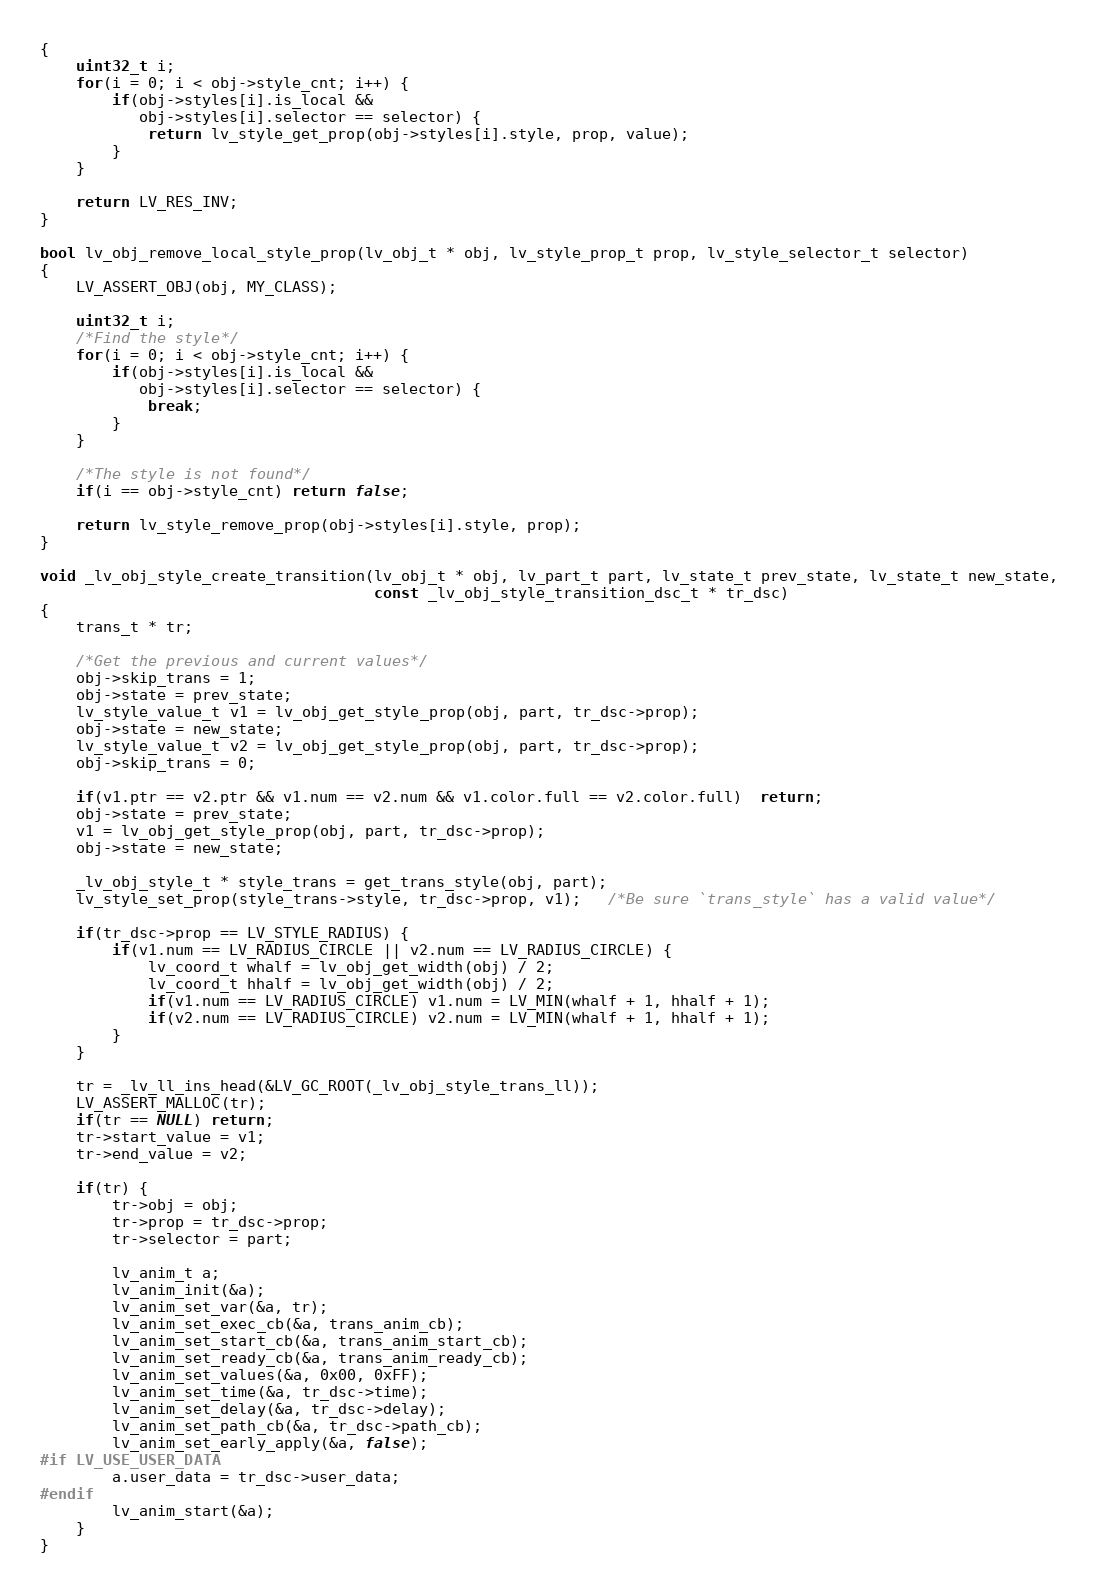<code> <loc_0><loc_0><loc_500><loc_500><_C_>{
    uint32_t i;
    for(i = 0; i < obj->style_cnt; i++) {
        if(obj->styles[i].is_local &&
           obj->styles[i].selector == selector) {
            return lv_style_get_prop(obj->styles[i].style, prop, value);
        }
    }

    return LV_RES_INV;
}

bool lv_obj_remove_local_style_prop(lv_obj_t * obj, lv_style_prop_t prop, lv_style_selector_t selector)
{
    LV_ASSERT_OBJ(obj, MY_CLASS);

    uint32_t i;
    /*Find the style*/
    for(i = 0; i < obj->style_cnt; i++) {
        if(obj->styles[i].is_local &&
           obj->styles[i].selector == selector) {
            break;
        }
    }

    /*The style is not found*/
    if(i == obj->style_cnt) return false;

    return lv_style_remove_prop(obj->styles[i].style, prop);
}

void _lv_obj_style_create_transition(lv_obj_t * obj, lv_part_t part, lv_state_t prev_state, lv_state_t new_state,
                                     const _lv_obj_style_transition_dsc_t * tr_dsc)
{
    trans_t * tr;

    /*Get the previous and current values*/
    obj->skip_trans = 1;
    obj->state = prev_state;
    lv_style_value_t v1 = lv_obj_get_style_prop(obj, part, tr_dsc->prop);
    obj->state = new_state;
    lv_style_value_t v2 = lv_obj_get_style_prop(obj, part, tr_dsc->prop);
    obj->skip_trans = 0;

    if(v1.ptr == v2.ptr && v1.num == v2.num && v1.color.full == v2.color.full)  return;
    obj->state = prev_state;
    v1 = lv_obj_get_style_prop(obj, part, tr_dsc->prop);
    obj->state = new_state;

    _lv_obj_style_t * style_trans = get_trans_style(obj, part);
    lv_style_set_prop(style_trans->style, tr_dsc->prop, v1);   /*Be sure `trans_style` has a valid value*/

    if(tr_dsc->prop == LV_STYLE_RADIUS) {
        if(v1.num == LV_RADIUS_CIRCLE || v2.num == LV_RADIUS_CIRCLE) {
            lv_coord_t whalf = lv_obj_get_width(obj) / 2;
            lv_coord_t hhalf = lv_obj_get_width(obj) / 2;
            if(v1.num == LV_RADIUS_CIRCLE) v1.num = LV_MIN(whalf + 1, hhalf + 1);
            if(v2.num == LV_RADIUS_CIRCLE) v2.num = LV_MIN(whalf + 1, hhalf + 1);
        }
    }

    tr = _lv_ll_ins_head(&LV_GC_ROOT(_lv_obj_style_trans_ll));
    LV_ASSERT_MALLOC(tr);
    if(tr == NULL) return;
    tr->start_value = v1;
    tr->end_value = v2;

    if(tr) {
        tr->obj = obj;
        tr->prop = tr_dsc->prop;
        tr->selector = part;

        lv_anim_t a;
        lv_anim_init(&a);
        lv_anim_set_var(&a, tr);
        lv_anim_set_exec_cb(&a, trans_anim_cb);
        lv_anim_set_start_cb(&a, trans_anim_start_cb);
        lv_anim_set_ready_cb(&a, trans_anim_ready_cb);
        lv_anim_set_values(&a, 0x00, 0xFF);
        lv_anim_set_time(&a, tr_dsc->time);
        lv_anim_set_delay(&a, tr_dsc->delay);
        lv_anim_set_path_cb(&a, tr_dsc->path_cb);
        lv_anim_set_early_apply(&a, false);
#if LV_USE_USER_DATA
        a.user_data = tr_dsc->user_data;
#endif
        lv_anim_start(&a);
    }
}

</code> 